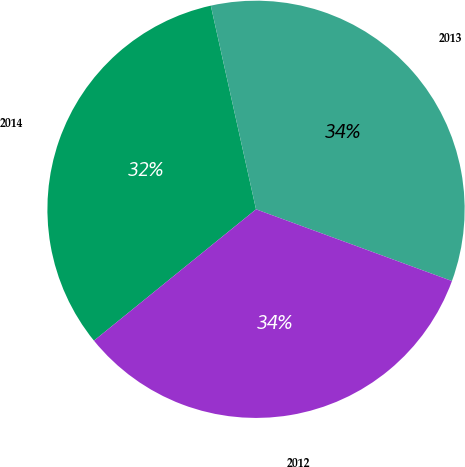Convert chart. <chart><loc_0><loc_0><loc_500><loc_500><pie_chart><fcel>2014<fcel>2013<fcel>2012<nl><fcel>32.36%<fcel>34.06%<fcel>33.57%<nl></chart> 